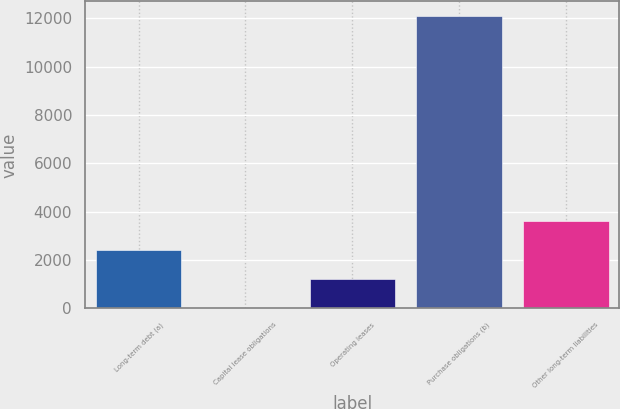Convert chart to OTSL. <chart><loc_0><loc_0><loc_500><loc_500><bar_chart><fcel>Long-term debt (a)<fcel>Capital lease obligations<fcel>Operating leases<fcel>Purchase obligations (b)<fcel>Other long-term liabilities<nl><fcel>2421.2<fcel>4<fcel>1212.6<fcel>12090<fcel>3629.8<nl></chart> 